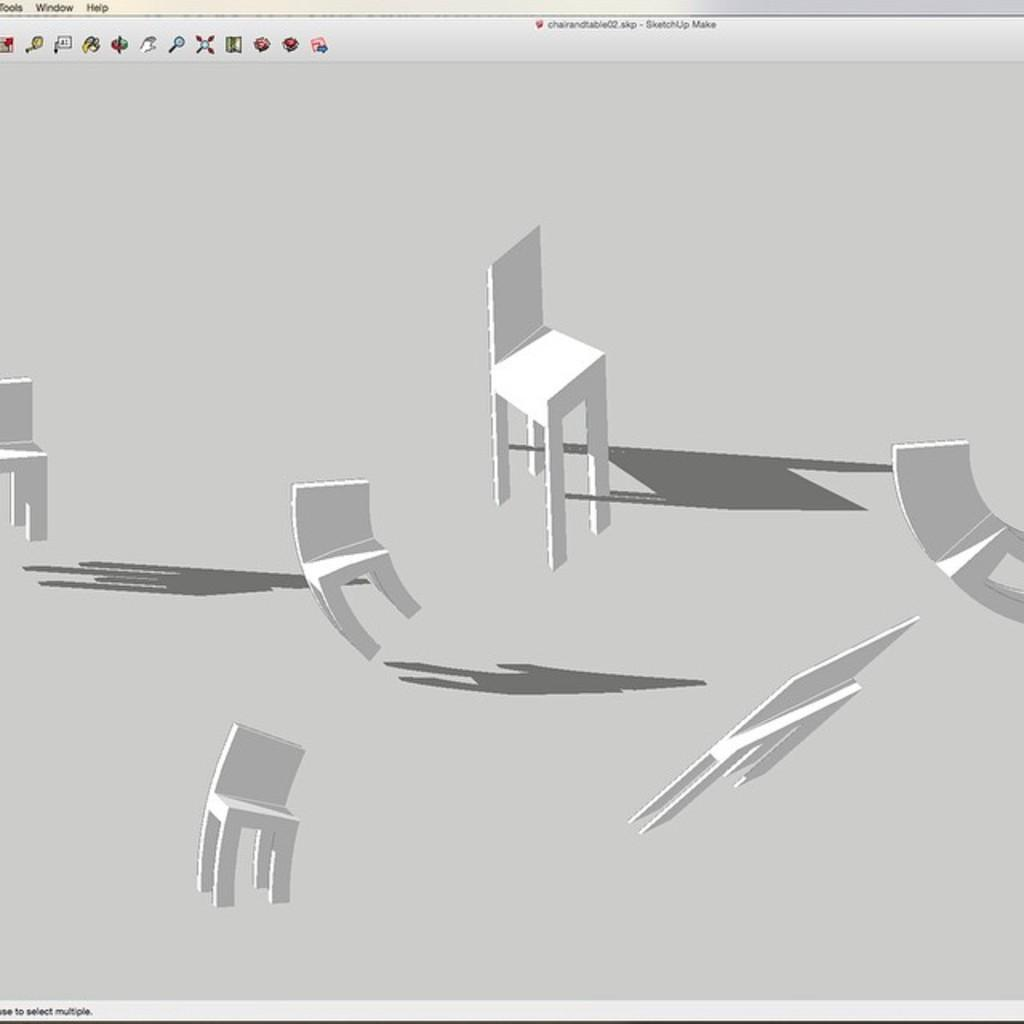What is the main subject of the image? The main subject of the image is a browser. Are there any objects in the image besides the browser? Yes, there are chairs in the image. How are the chairs positioned in relation to each other? The chairs are at different angles in the image. What can be seen at the top of the image? There are icons visible at the top of the image. What type of treatment is being administered to the elbow in the image? There is no elbow or treatment present in the image; it is a picture of a browser with chairs at different angles. 